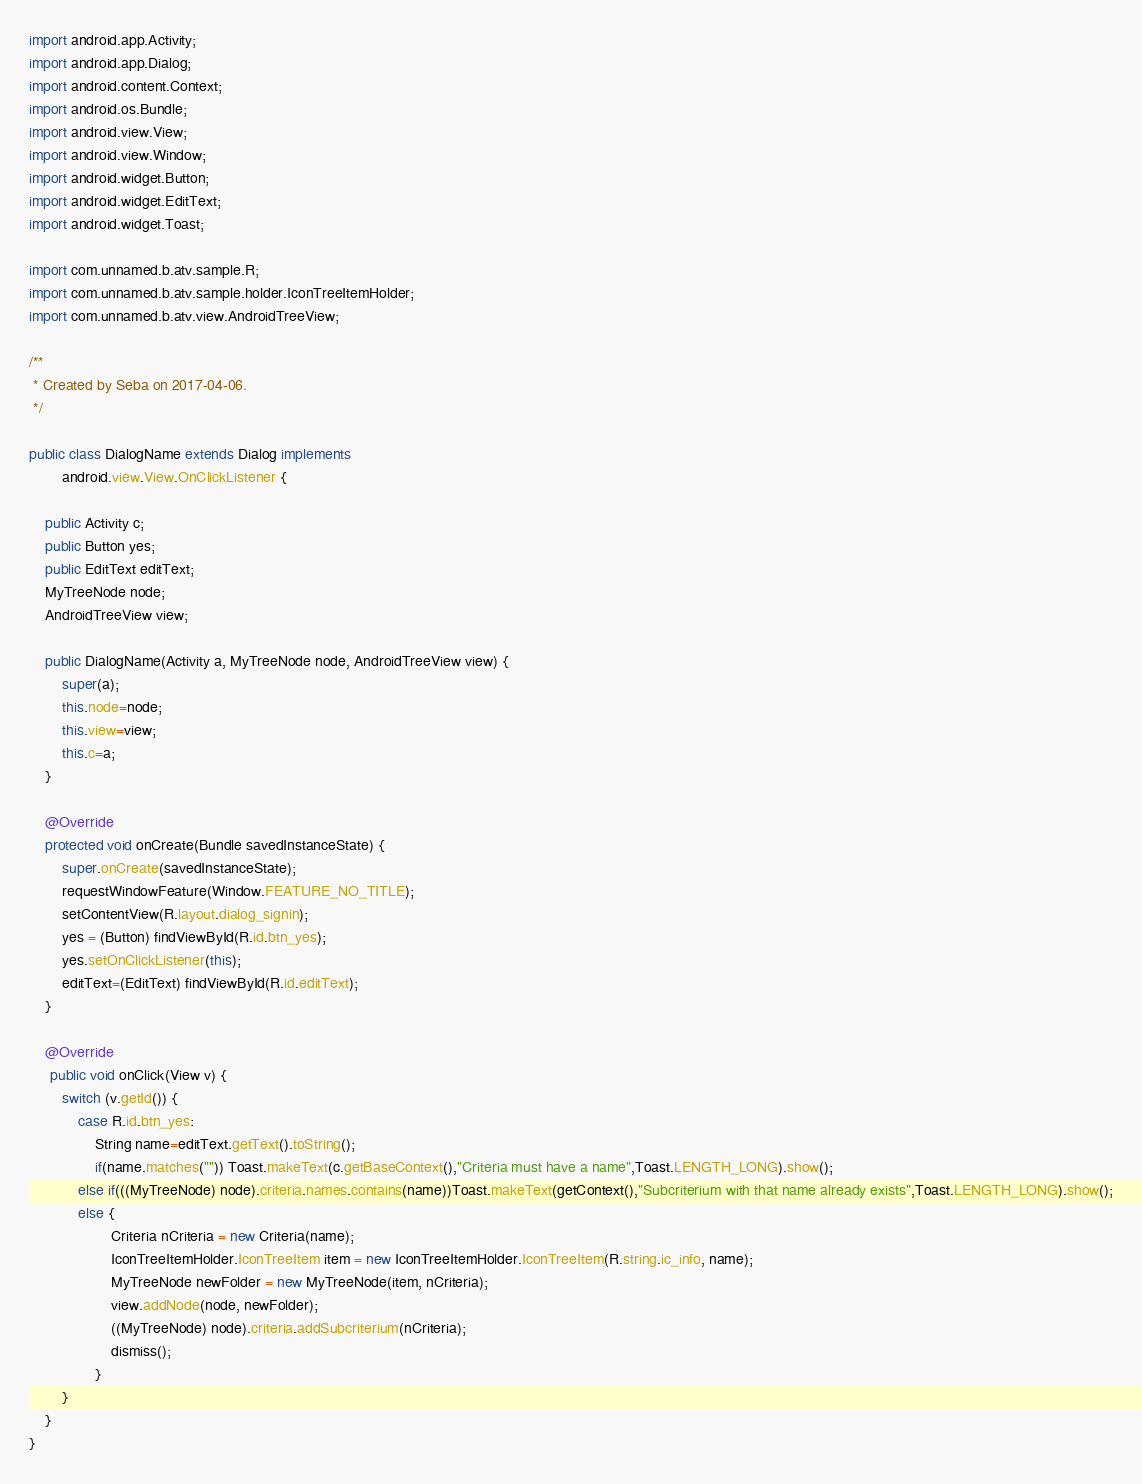Convert code to text. <code><loc_0><loc_0><loc_500><loc_500><_Java_>import android.app.Activity;
import android.app.Dialog;
import android.content.Context;
import android.os.Bundle;
import android.view.View;
import android.view.Window;
import android.widget.Button;
import android.widget.EditText;
import android.widget.Toast;

import com.unnamed.b.atv.sample.R;
import com.unnamed.b.atv.sample.holder.IconTreeItemHolder;
import com.unnamed.b.atv.view.AndroidTreeView;

/**
 * Created by Seba on 2017-04-06.
 */

public class DialogName extends Dialog implements
        android.view.View.OnClickListener {

    public Activity c;
    public Button yes;
    public EditText editText;
    MyTreeNode node;
    AndroidTreeView view;

    public DialogName(Activity a, MyTreeNode node, AndroidTreeView view) {
        super(a);
        this.node=node;
        this.view=view;
        this.c=a;
    }

    @Override
    protected void onCreate(Bundle savedInstanceState) {
        super.onCreate(savedInstanceState);
        requestWindowFeature(Window.FEATURE_NO_TITLE);
        setContentView(R.layout.dialog_signin);
        yes = (Button) findViewById(R.id.btn_yes);
        yes.setOnClickListener(this);
        editText=(EditText) findViewById(R.id.editText);
    }

    @Override
     public void onClick(View v) {
        switch (v.getId()) {
            case R.id.btn_yes:
                String name=editText.getText().toString();
                if(name.matches("")) Toast.makeText(c.getBaseContext(),"Criteria must have a name",Toast.LENGTH_LONG).show();
            else if(((MyTreeNode) node).criteria.names.contains(name))Toast.makeText(getContext(),"Subcriterium with that name already exists",Toast.LENGTH_LONG).show();
            else {
                    Criteria nCriteria = new Criteria(name);
                    IconTreeItemHolder.IconTreeItem item = new IconTreeItemHolder.IconTreeItem(R.string.ic_info, name);
                    MyTreeNode newFolder = new MyTreeNode(item, nCriteria);
                    view.addNode(node, newFolder);
                    ((MyTreeNode) node).criteria.addSubcriterium(nCriteria);
                    dismiss();
                }
        }
    }
}</code> 